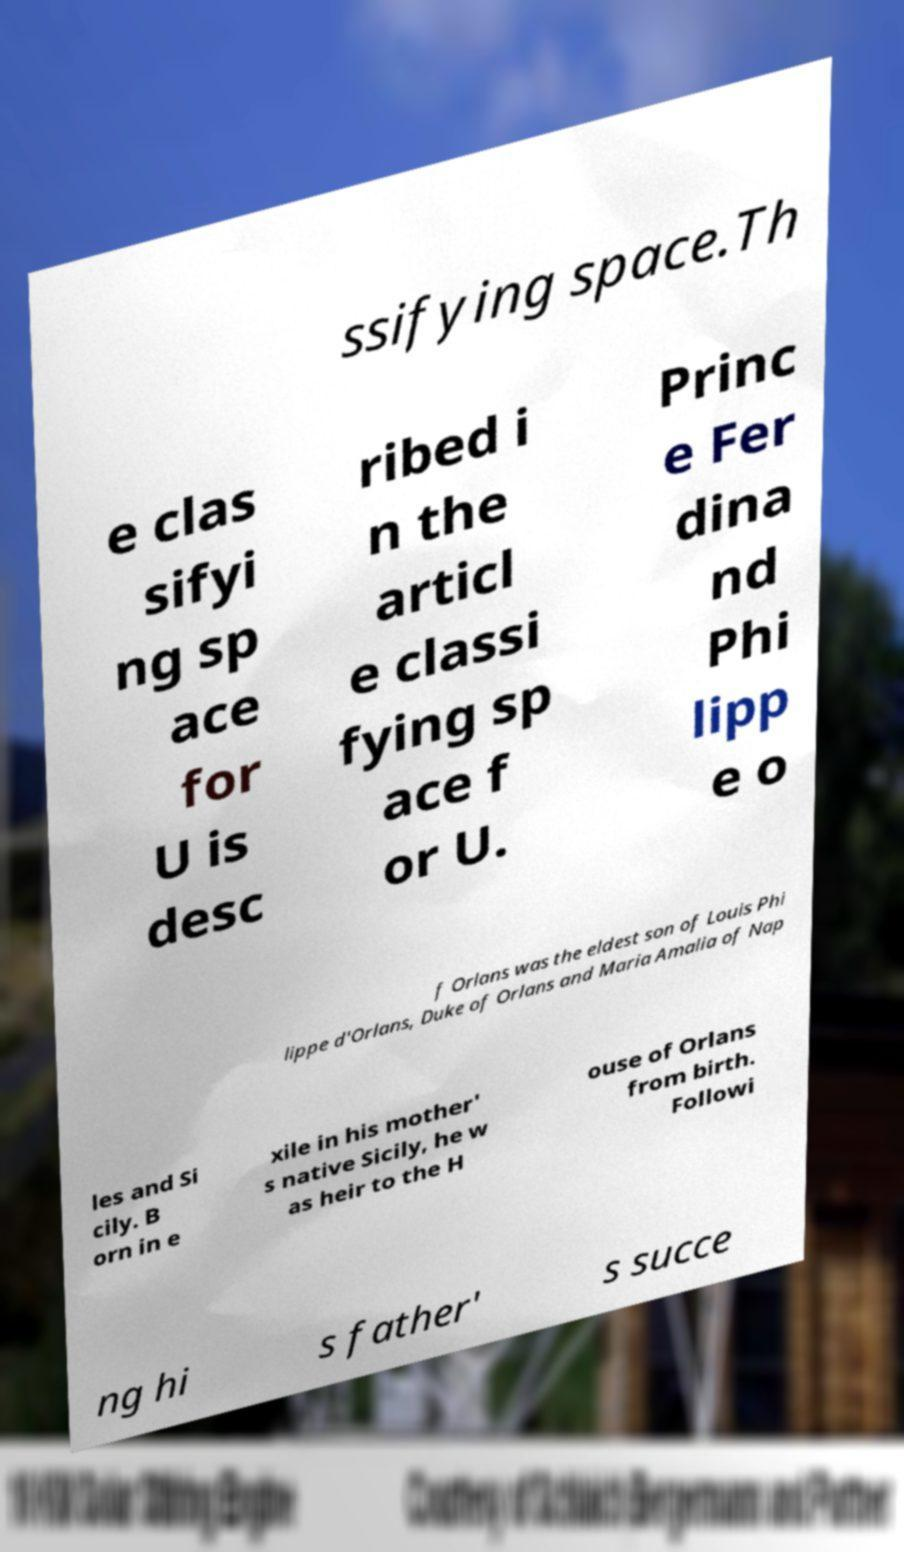For documentation purposes, I need the text within this image transcribed. Could you provide that? ssifying space.Th e clas sifyi ng sp ace for U is desc ribed i n the articl e classi fying sp ace f or U. Princ e Fer dina nd Phi lipp e o f Orlans was the eldest son of Louis Phi lippe d'Orlans, Duke of Orlans and Maria Amalia of Nap les and Si cily. B orn in e xile in his mother' s native Sicily, he w as heir to the H ouse of Orlans from birth. Followi ng hi s father' s succe 